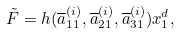<formula> <loc_0><loc_0><loc_500><loc_500>\tilde { F } = h ( \overline { a } _ { 1 1 } ^ { ( i ) } , \overline { a } _ { 2 1 } ^ { ( i ) } , \overline { a } _ { 3 1 } ^ { ( i ) } ) x _ { 1 } ^ { d } ,</formula> 